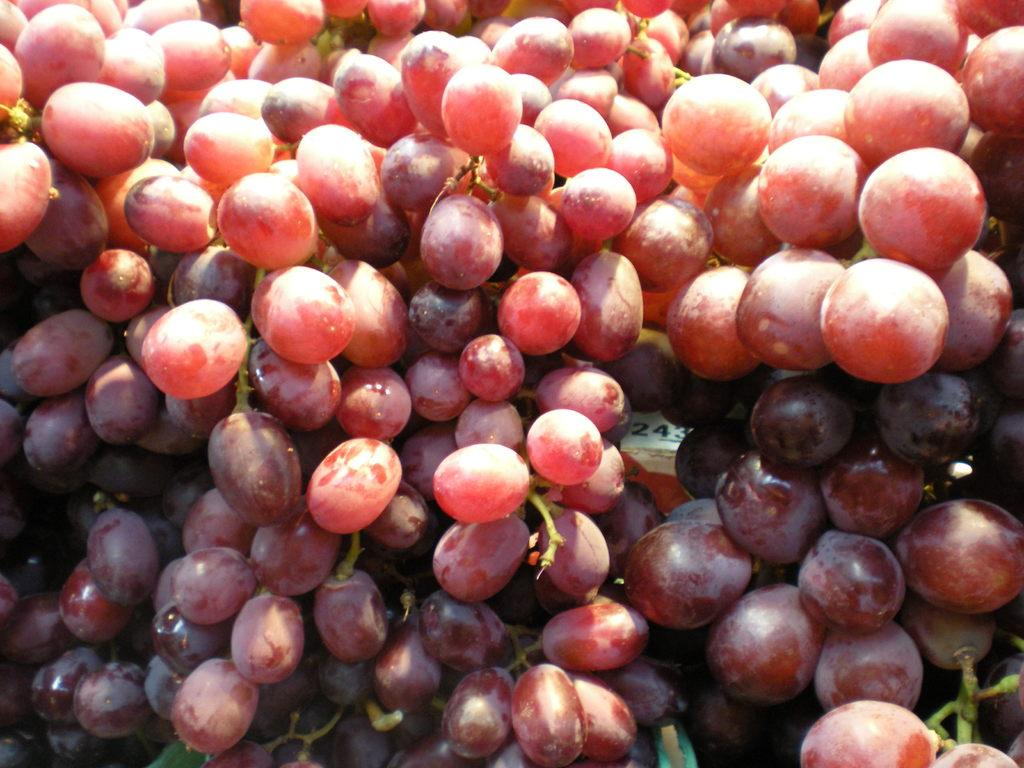What type of fruit is present in the image? There are grapes in the image. What else can be seen on the white surface in the image? There are numbers on a white surface in the image. What color is the alarm in the image? There is no alarm present in the image. How does the light affect the color of the grapes in the image? The image does not provide information about the lighting conditions, so we cannot determine how the light affects the color of the grapes. 